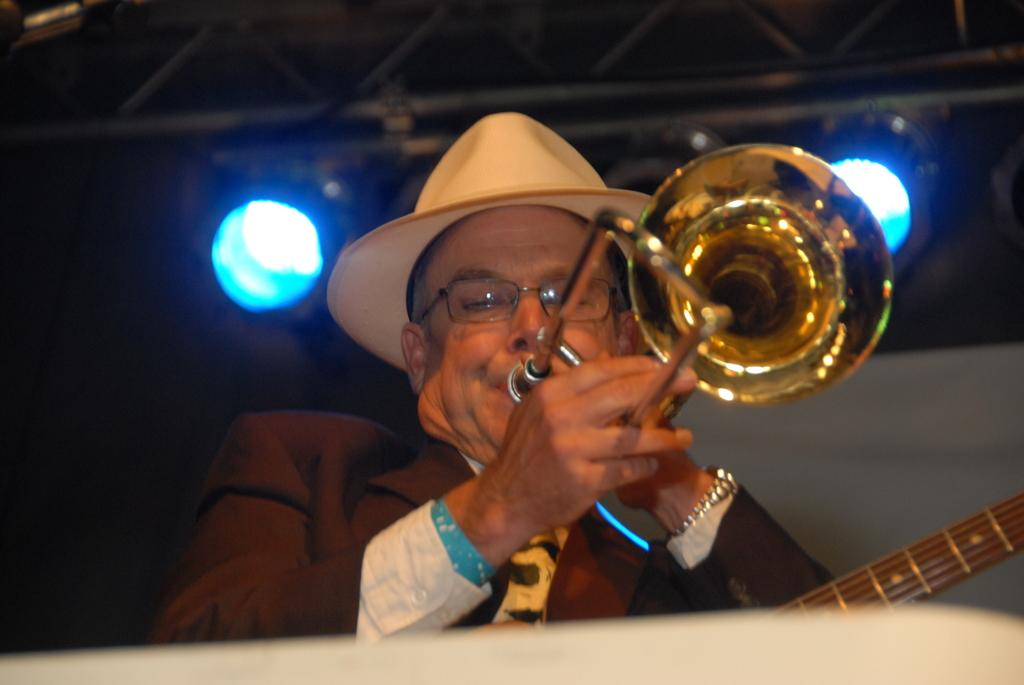Who is the main subject in the image? There is a man in the center of the image. What is the man doing in the image? The man is playing a trumpet. Can you describe the man's attire in the image? The man is wearing a hat. What can be seen in the background of the image? There are lights and a wall in the background of the image. How many babies are playing with balls in the image? There are no babies or balls present in the image. What type of drug can be seen in the man's hand in the image? There is no drug visible in the man's hand or anywhere else in the image. 